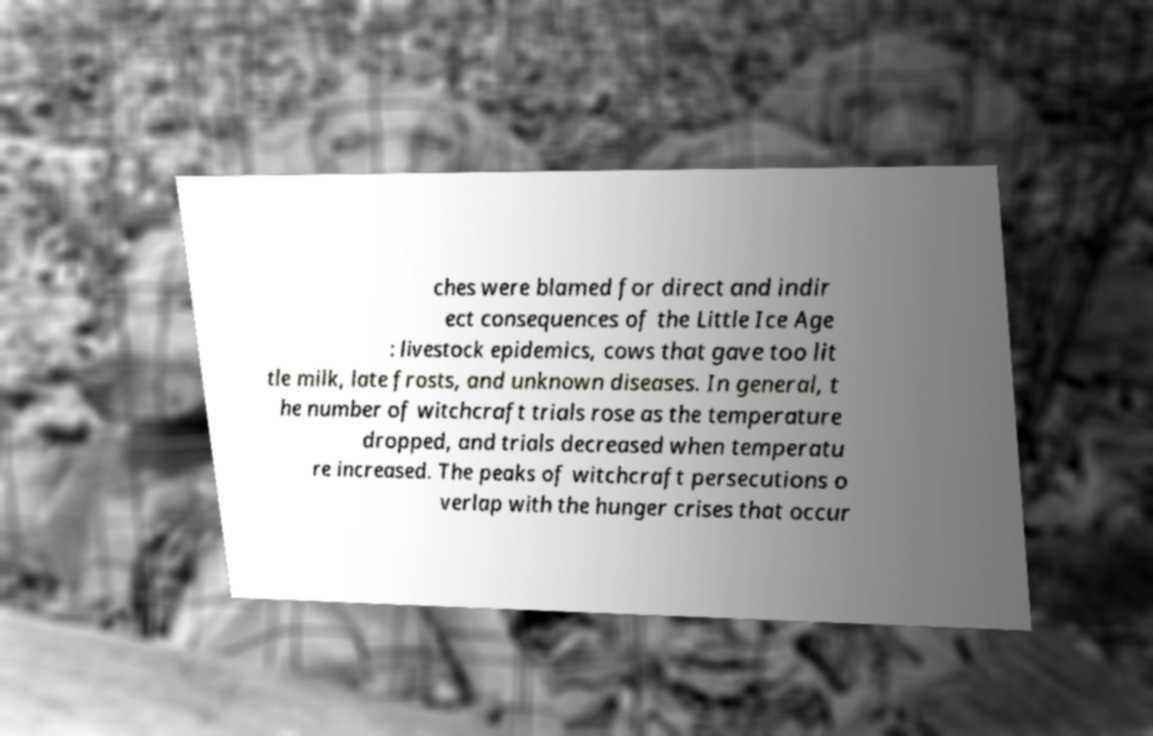What messages or text are displayed in this image? I need them in a readable, typed format. ches were blamed for direct and indir ect consequences of the Little Ice Age : livestock epidemics, cows that gave too lit tle milk, late frosts, and unknown diseases. In general, t he number of witchcraft trials rose as the temperature dropped, and trials decreased when temperatu re increased. The peaks of witchcraft persecutions o verlap with the hunger crises that occur 